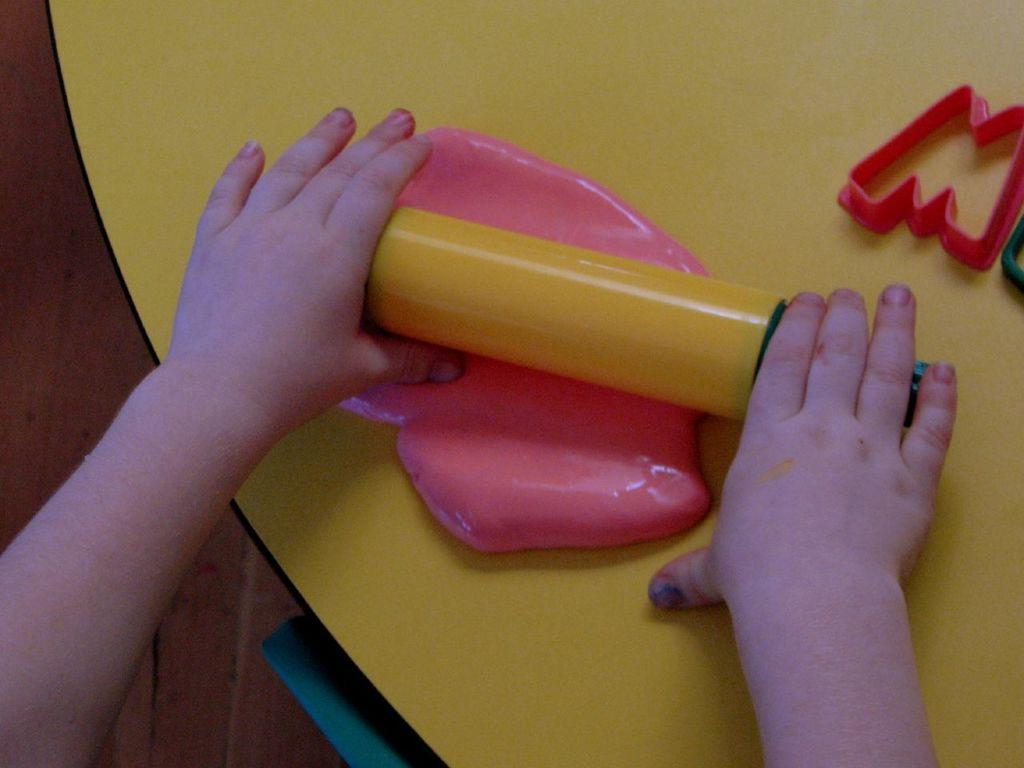Who is in the image? There is a person in the image. What is the person doing in the image? The person is playing with clay. What objects are on the table in the image? There are moulds on the table. What can be seen in the background of the image? There is a floor visible in the background. What type of pan is being used to catch the fish in the image? There is no pan or fish present in the image; it features a person playing with clay and moulds on a table. How many stitches are visible on the person's clothing in the image? There is no information about the person's clothing or stitches in the image. 